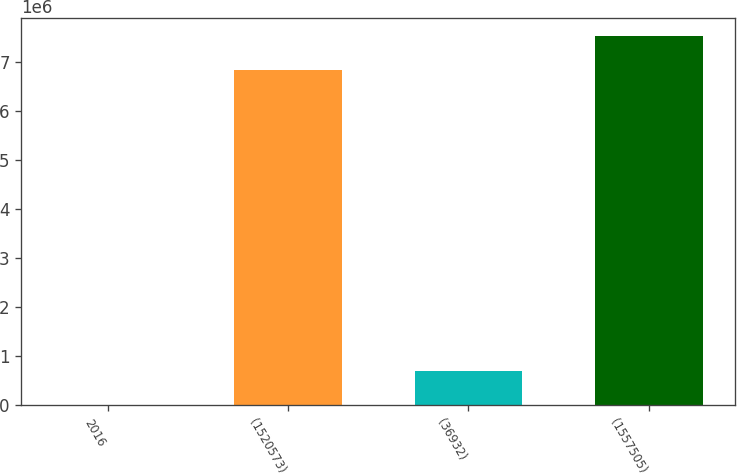Convert chart. <chart><loc_0><loc_0><loc_500><loc_500><bar_chart><fcel>2016<fcel>(1520573)<fcel>(36932)<fcel>(1557505)<nl><fcel>2015<fcel>6.84012e+06<fcel>693969<fcel>7.53207e+06<nl></chart> 